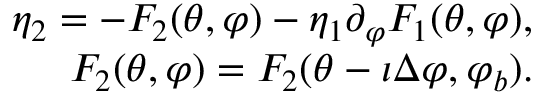<formula> <loc_0><loc_0><loc_500><loc_500>\begin{array} { r } { \eta _ { 2 } = - F _ { 2 } ( \theta , \varphi ) - \eta _ { 1 } \partial _ { \varphi } F _ { 1 } ( \theta , \varphi ) , } \\ { F _ { 2 } ( \theta , \varphi ) = F _ { 2 } ( \theta - \iota \Delta \varphi , \varphi _ { b } ) . } \end{array}</formula> 